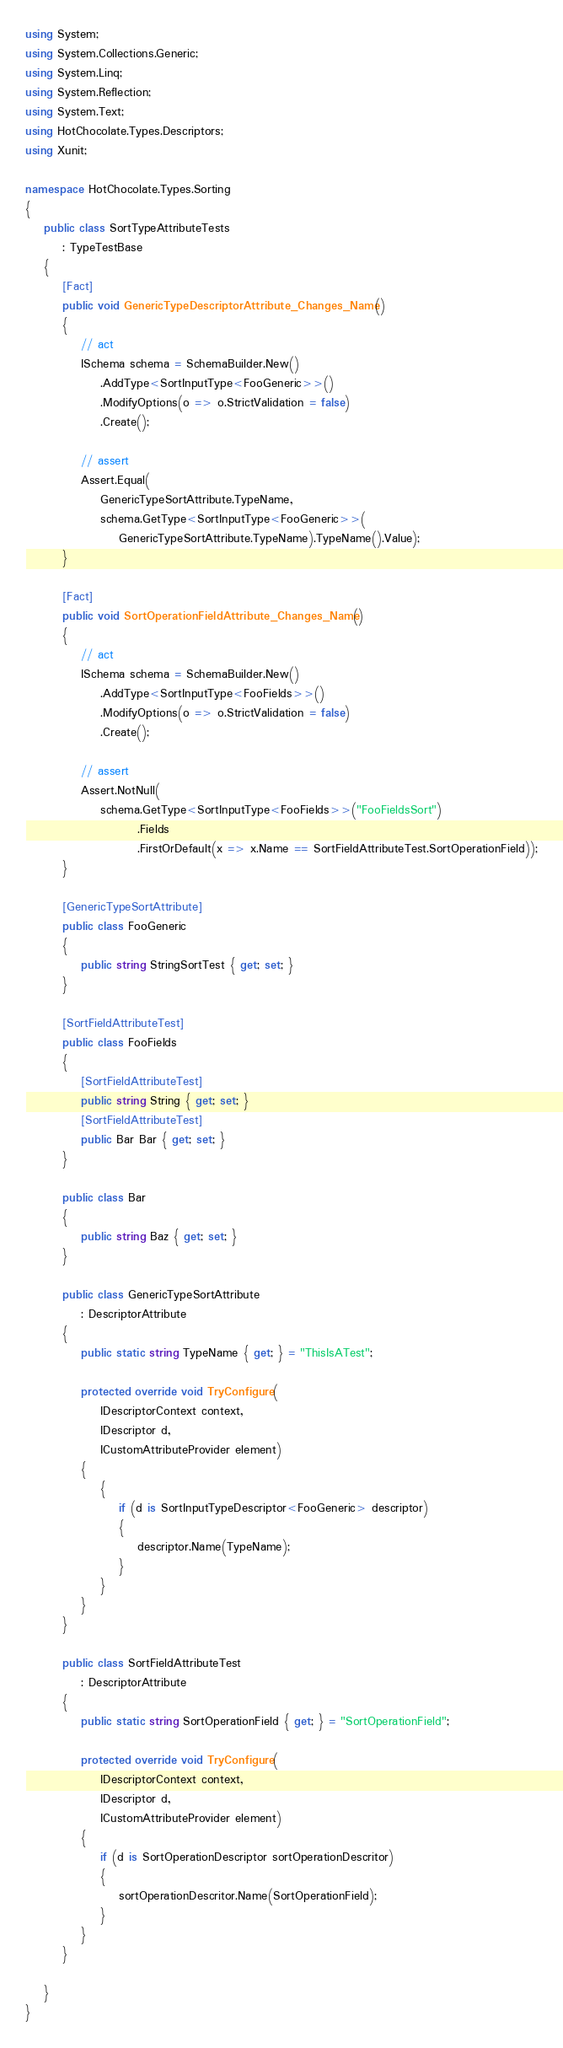<code> <loc_0><loc_0><loc_500><loc_500><_C#_>using System;
using System.Collections.Generic;
using System.Linq;
using System.Reflection;
using System.Text;
using HotChocolate.Types.Descriptors;
using Xunit;

namespace HotChocolate.Types.Sorting
{
    public class SortTypeAttributeTests
        : TypeTestBase
    {
        [Fact]
        public void GenericTypeDescriptorAttribute_Changes_Name()
        {
            // act
            ISchema schema = SchemaBuilder.New()
                .AddType<SortInputType<FooGeneric>>()
                .ModifyOptions(o => o.StrictValidation = false)
                .Create();

            // assert
            Assert.Equal(
                GenericTypeSortAttribute.TypeName,
                schema.GetType<SortInputType<FooGeneric>>(
                    GenericTypeSortAttribute.TypeName).TypeName().Value);
        }

        [Fact]
        public void SortOperationFieldAttribute_Changes_Name()
        {
            // act
            ISchema schema = SchemaBuilder.New()
                .AddType<SortInputType<FooFields>>()
                .ModifyOptions(o => o.StrictValidation = false)
                .Create();

            // assert
            Assert.NotNull(
                schema.GetType<SortInputType<FooFields>>("FooFieldsSort")
                        .Fields
                        .FirstOrDefault(x => x.Name == SortFieldAttributeTest.SortOperationField));
        }

        [GenericTypeSortAttribute]
        public class FooGeneric
        {
            public string StringSortTest { get; set; }
        }

        [SortFieldAttributeTest]
        public class FooFields
        {
            [SortFieldAttributeTest]
            public string String { get; set; }
            [SortFieldAttributeTest]
            public Bar Bar { get; set; }
        }

        public class Bar
        {
            public string Baz { get; set; }
        }

        public class GenericTypeSortAttribute
            : DescriptorAttribute
        {
            public static string TypeName { get; } = "ThisIsATest";

            protected override void TryConfigure(
                IDescriptorContext context,
                IDescriptor d,
                ICustomAttributeProvider element)
            {
                {
                    if (d is SortInputTypeDescriptor<FooGeneric> descriptor)
                    {
                        descriptor.Name(TypeName);
                    }
                }
            }
        }

        public class SortFieldAttributeTest
            : DescriptorAttribute
        {
            public static string SortOperationField { get; } = "SortOperationField";

            protected override void TryConfigure(
                IDescriptorContext context,
                IDescriptor d,
                ICustomAttributeProvider element)
            {
                if (d is SortOperationDescriptor sortOperationDescritor)
                {
                    sortOperationDescritor.Name(SortOperationField);
                }
            }
        }

    }
}
</code> 